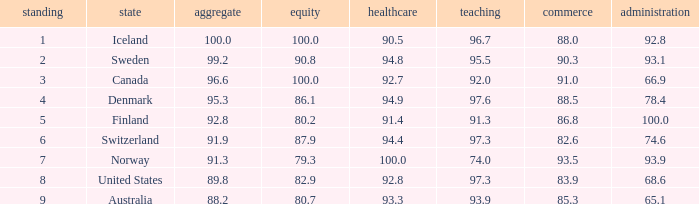What's the health score with justice being 80.7 93.3. 